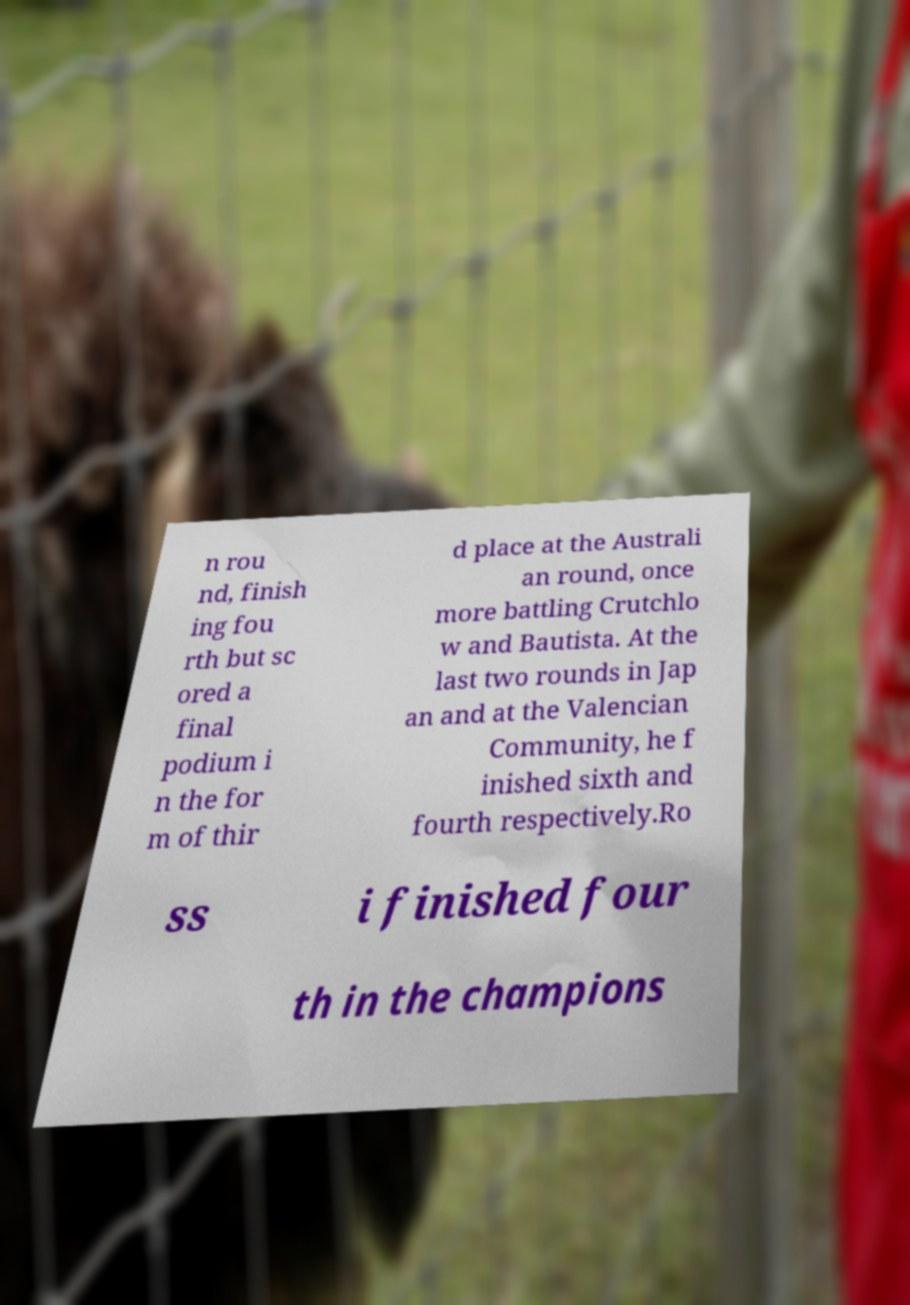For documentation purposes, I need the text within this image transcribed. Could you provide that? n rou nd, finish ing fou rth but sc ored a final podium i n the for m of thir d place at the Australi an round, once more battling Crutchlo w and Bautista. At the last two rounds in Jap an and at the Valencian Community, he f inished sixth and fourth respectively.Ro ss i finished four th in the champions 